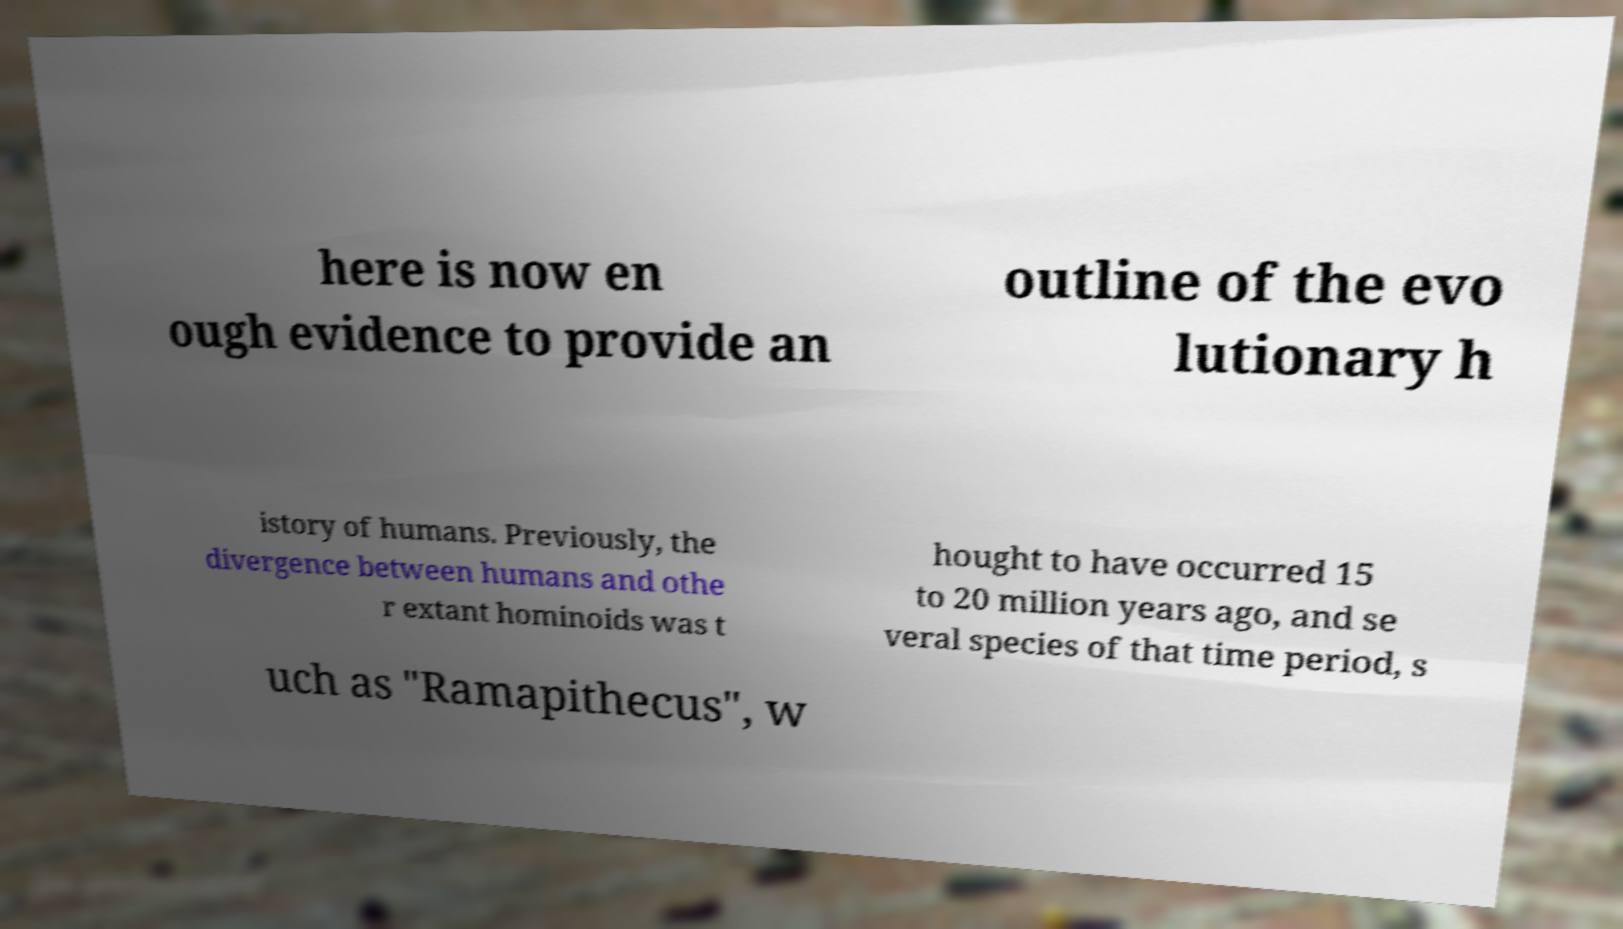Could you extract and type out the text from this image? here is now en ough evidence to provide an outline of the evo lutionary h istory of humans. Previously, the divergence between humans and othe r extant hominoids was t hought to have occurred 15 to 20 million years ago, and se veral species of that time period, s uch as "Ramapithecus", w 